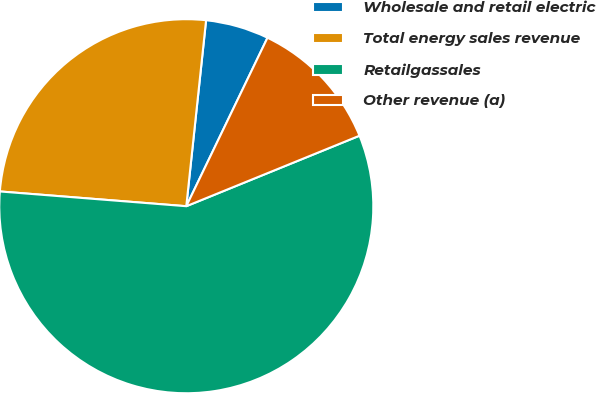Convert chart. <chart><loc_0><loc_0><loc_500><loc_500><pie_chart><fcel>Wholesale and retail electric<fcel>Total energy sales revenue<fcel>Retailgassales<fcel>Other revenue (a)<nl><fcel>5.46%<fcel>25.43%<fcel>57.41%<fcel>11.7%<nl></chart> 